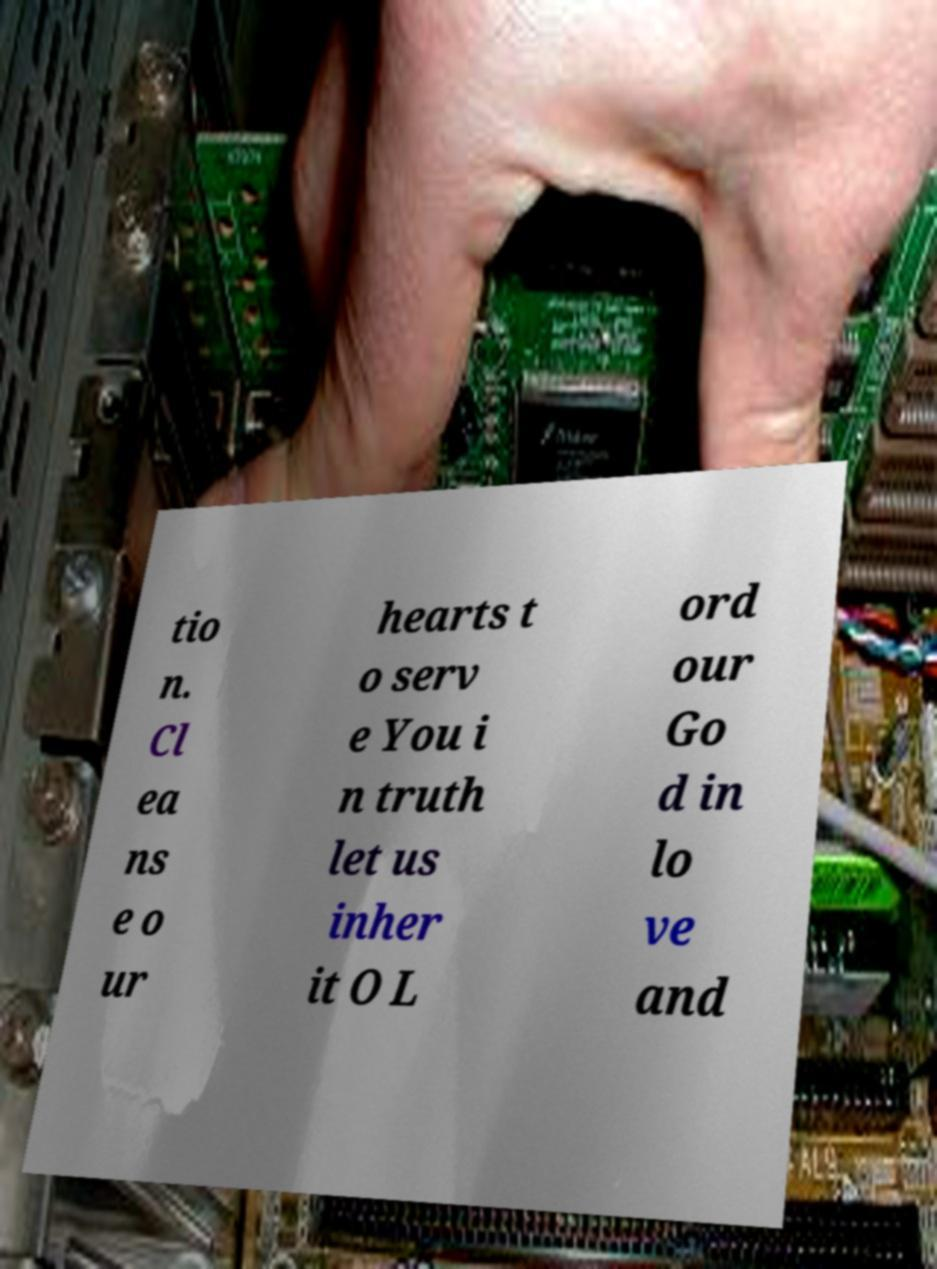Please identify and transcribe the text found in this image. tio n. Cl ea ns e o ur hearts t o serv e You i n truth let us inher it O L ord our Go d in lo ve and 